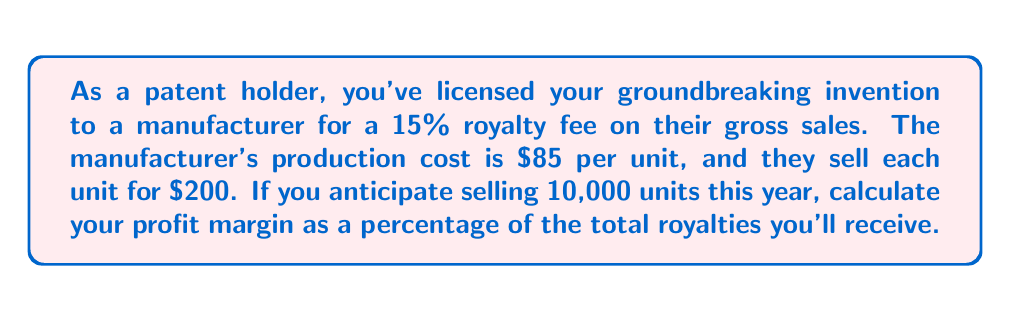What is the answer to this math problem? Let's break this down step-by-step:

1. Calculate the royalty fee per unit:
   Royalty fee = 15% of gross sales
   $$ \text{Royalty fee per unit} = 0.15 \times \$200 = \$30 $$

2. Calculate total royalties for 10,000 units:
   $$ \text{Total royalties} = \$30 \times 10,000 = \$300,000 $$

3. As the patent holder, your profit is equal to your total royalties, as you don't incur production costs.

4. To calculate profit margin as a percentage, we use the formula:
   $$ \text{Profit Margin} = \frac{\text{Profit}}{\text{Revenue}} \times 100\% $$

   In this case, your revenue is the same as your profit (total royalties), so:

   $$ \text{Profit Margin} = \frac{\$300,000}{\$300,000} \times 100\% = 100\% $$

Therefore, your profit margin as a percentage of the total royalties you'll receive is 100%.
Answer: 100% 